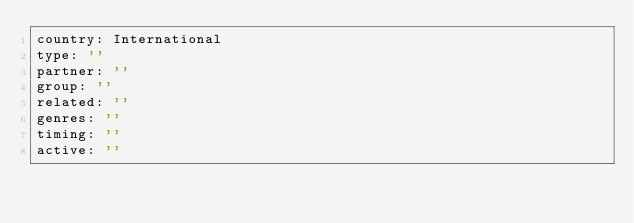<code> <loc_0><loc_0><loc_500><loc_500><_YAML_>country: International
type: ''
partner: ''
group: ''
related: ''
genres: ''
timing: ''
active: ''
</code> 